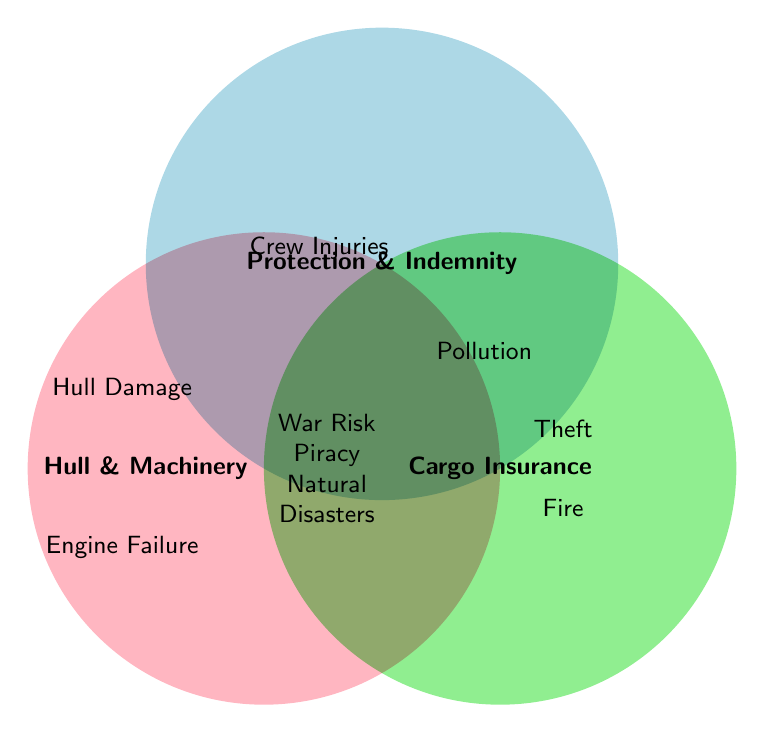What's covered under all three insurance types? The intersection area of all three circles represents coverage applicable under all insurance types. Those are War Risk, Piracy, and Natural Disasters.
Answer: War Risk, Piracy, Natural Disasters What specific type of damage is covered by Cargo Insurance but not by Protection & Indemnity? By looking at the Cargo Insurance circle without the overlapping areas with Protection & Indemnity, the specific coverages are Theft, Water Damage, and Fire Damage.
Answer: Theft, Water Damage, Fire What are the coverages specific to Hull and Machinery Insurance? The areas that only fall within the Hull and Machinery Insurance circle are Hull Damage, Engine Failure, and Navigation Equipment.
Answer: Hull Damage, Engine Failure, Navigation Equipment How many types of coverage are unique to Protection and Indemnity Insurance? The areas exclusive to Protection and Indemnity show Crew Injuries, Pollution Liability, and Collision Liability, totaling 3.
Answer: 3 Which insurance type provides coverage for engine failure? Only the Hull and Machinery circle includes Engine Failure.
Answer: Hull and Machinery Which group covers Pollution Liability? Pollution Liability is only present in the Protection and Indemnity circle.
Answer: Protection and Indemnity What coverages apply to both Hull and Machinery and Cargo Insurance? The overlap between Hull and Machinery and Cargo Insurance does not exist in the diagram, indicating there are no shared coverages between the two.
Answer: None If a ship faces Natural Disasters, which insurance types will cover it? Natural Disasters are covered by the areas where all three circles overlap, indicating all types of insurance cover it.
Answer: All How many types of coverage are included in the Hull and Machinery category? All areas within the Hull and Machinery circle add up to three unique coverages: Hull Damage, Engine Failure, and Navigation Equipment.
Answer: 3 Which insurance type covers the most kinds of damages/injuries? By counting each coverage type per category, Protection and Indemnity has the most coverages listed, with 3 unique.
Answer: Protection and Indemnity 